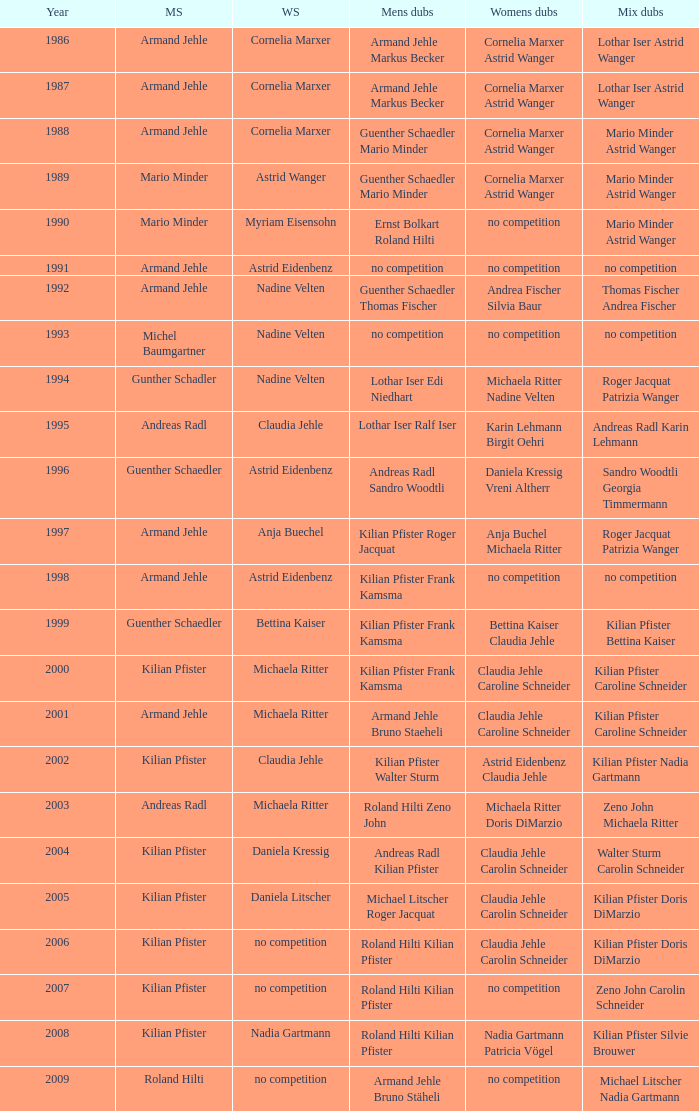In the year 2006, the womens singles had no competition and the mens doubles were roland hilti kilian pfister, what were the womens doubles Claudia Jehle Carolin Schneider. 